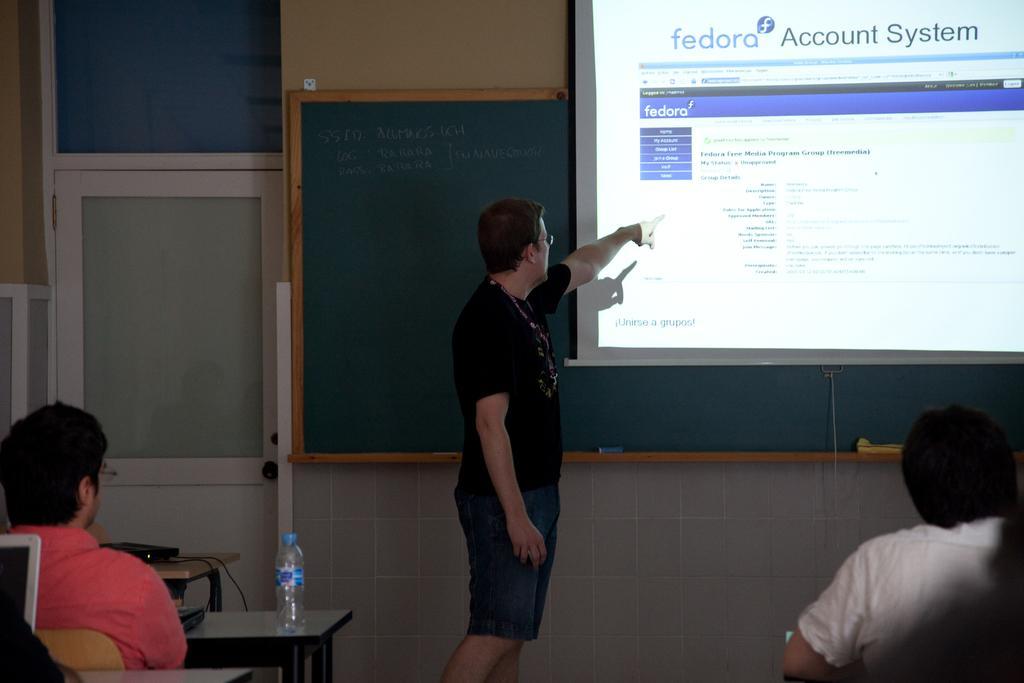How would you summarize this image in a sentence or two? In the center of the image we can see the person standing at the board. On the right side of the image we can see a screen and a person sitting. On the left side of the image we can see door and person sitting at the table. In the background there is a wall and board. 